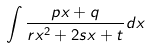<formula> <loc_0><loc_0><loc_500><loc_500>\int \frac { p x + q } { r x ^ { 2 } + 2 s x + t } d x</formula> 